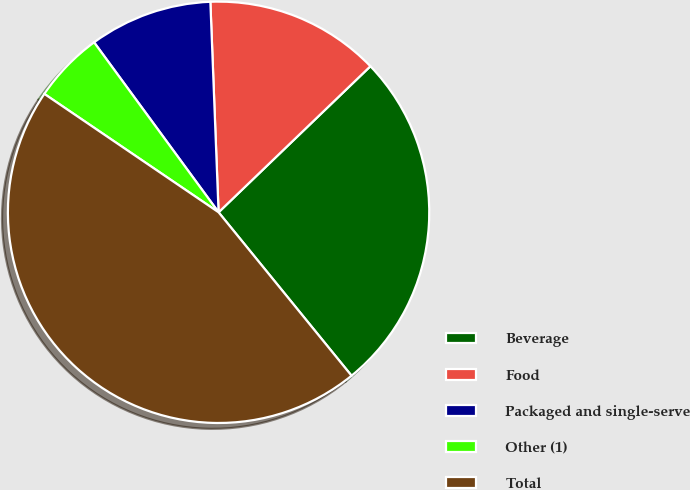Convert chart to OTSL. <chart><loc_0><loc_0><loc_500><loc_500><pie_chart><fcel>Beverage<fcel>Food<fcel>Packaged and single-serve<fcel>Other (1)<fcel>Total<nl><fcel>26.32%<fcel>13.43%<fcel>9.44%<fcel>5.44%<fcel>45.37%<nl></chart> 